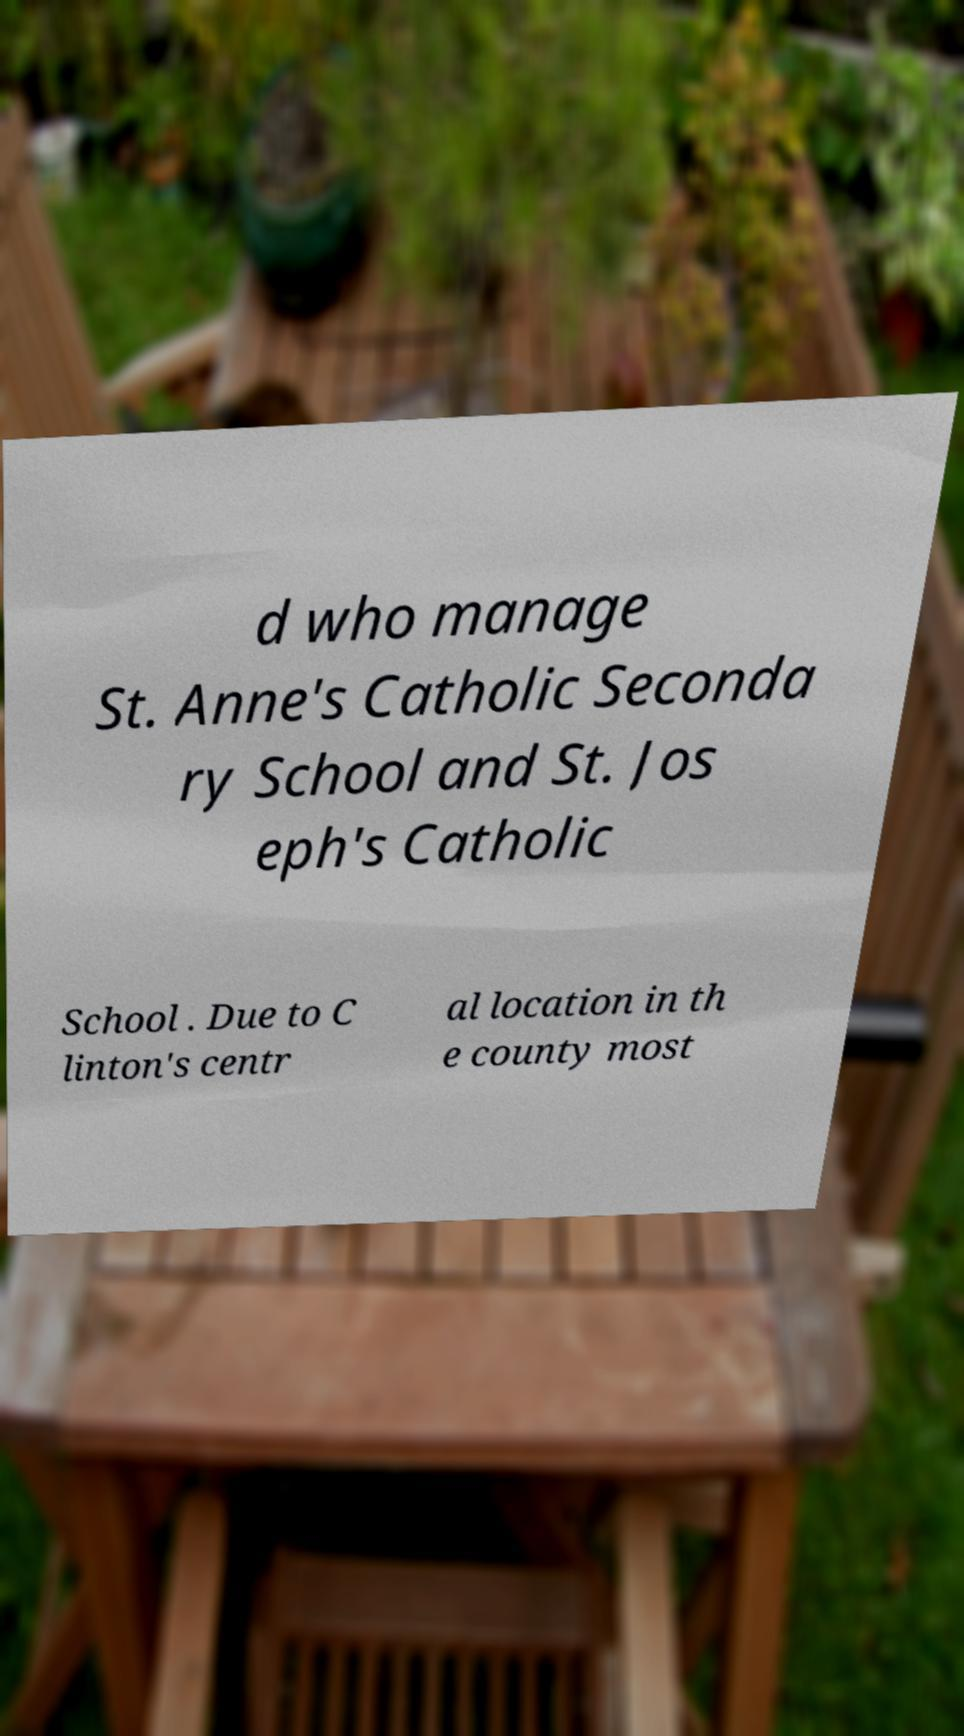There's text embedded in this image that I need extracted. Can you transcribe it verbatim? d who manage St. Anne's Catholic Seconda ry School and St. Jos eph's Catholic School . Due to C linton's centr al location in th e county most 